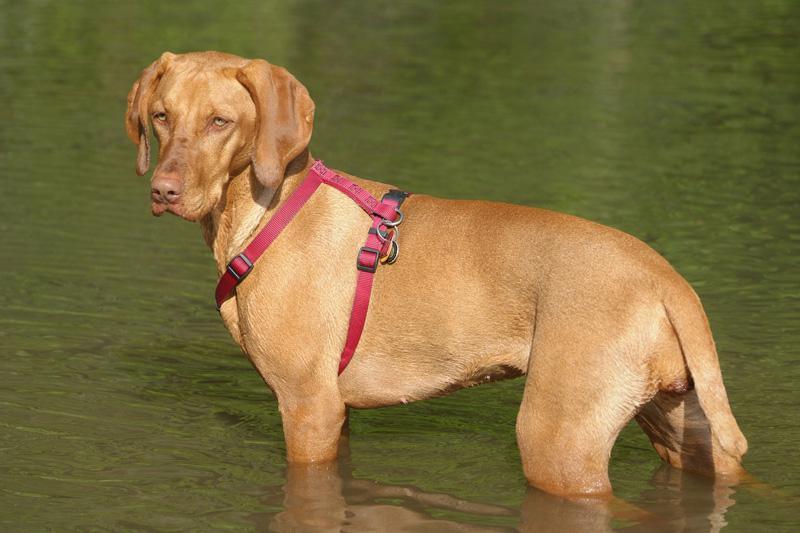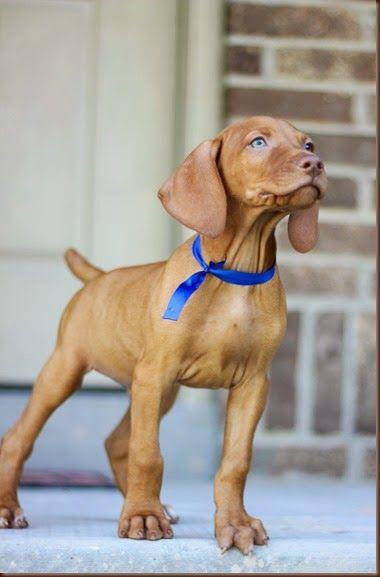The first image is the image on the left, the second image is the image on the right. Assess this claim about the two images: "A brown dog stand straight looking to the left while on the grass.". Correct or not? Answer yes or no. No. The first image is the image on the left, the second image is the image on the right. Given the left and right images, does the statement "At least one image shows one red-orange dog standing with head and body in profile turned leftward, and tail extended." hold true? Answer yes or no. No. 